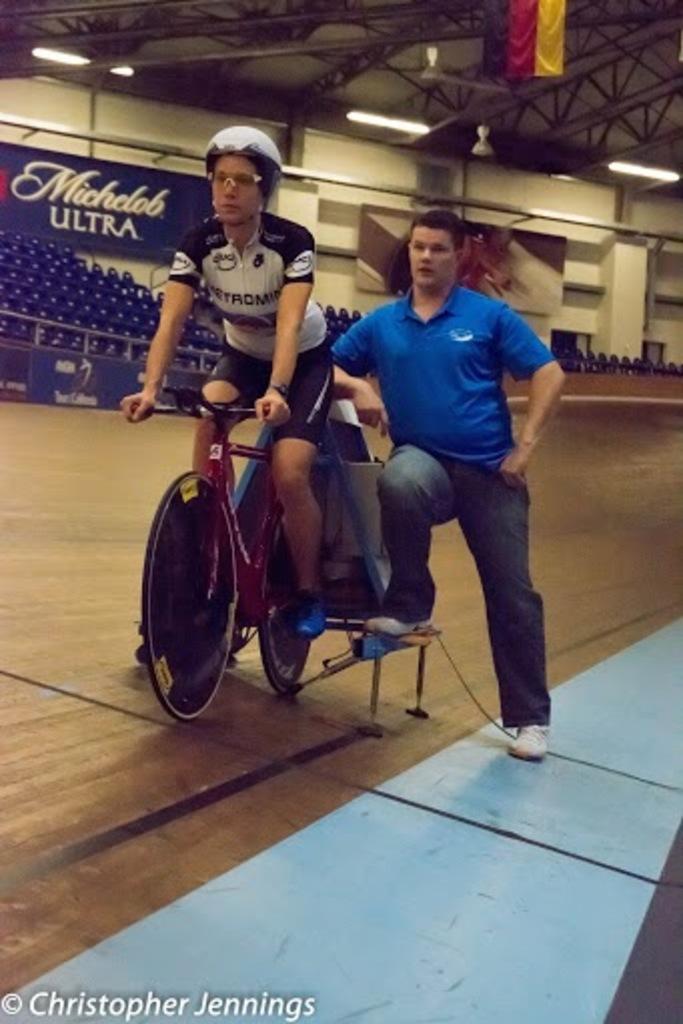Can you describe this image briefly? In this picture we can see a bicycle on the floor, here we can see two people and in the background we can see the wall, lights, boards, roof and some objects, in the bottom left we can see some text. 